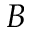Convert formula to latex. <formula><loc_0><loc_0><loc_500><loc_500>B</formula> 